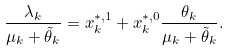<formula> <loc_0><loc_0><loc_500><loc_500>\frac { \lambda _ { k } } { \mu _ { k } + \tilde { \theta } _ { k } } = x _ { k } ^ { * , 1 } + x _ { k } ^ { * , 0 } \frac { \theta _ { k } } { \mu _ { k } + \tilde { \theta } _ { k } } .</formula> 